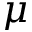Convert formula to latex. <formula><loc_0><loc_0><loc_500><loc_500>\mu</formula> 